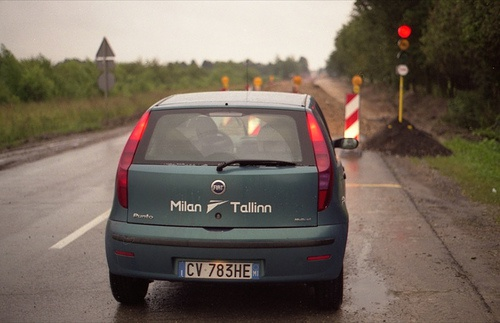Describe the objects in this image and their specific colors. I can see car in darkgray, gray, black, and purple tones and traffic light in darkgray, black, maroon, and red tones in this image. 